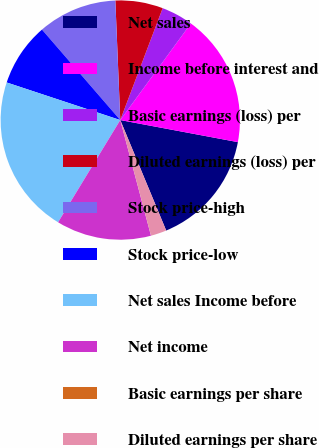Convert chart to OTSL. <chart><loc_0><loc_0><loc_500><loc_500><pie_chart><fcel>Net sales<fcel>Income before interest and<fcel>Basic earnings (loss) per<fcel>Diluted earnings (loss) per<fcel>Stock price-high<fcel>Stock price-low<fcel>Net sales Income before<fcel>Net income<fcel>Basic earnings per share<fcel>Diluted earnings per share<nl><fcel>15.78%<fcel>17.91%<fcel>4.28%<fcel>6.42%<fcel>10.7%<fcel>8.56%<fcel>21.39%<fcel>12.83%<fcel>0.0%<fcel>2.14%<nl></chart> 